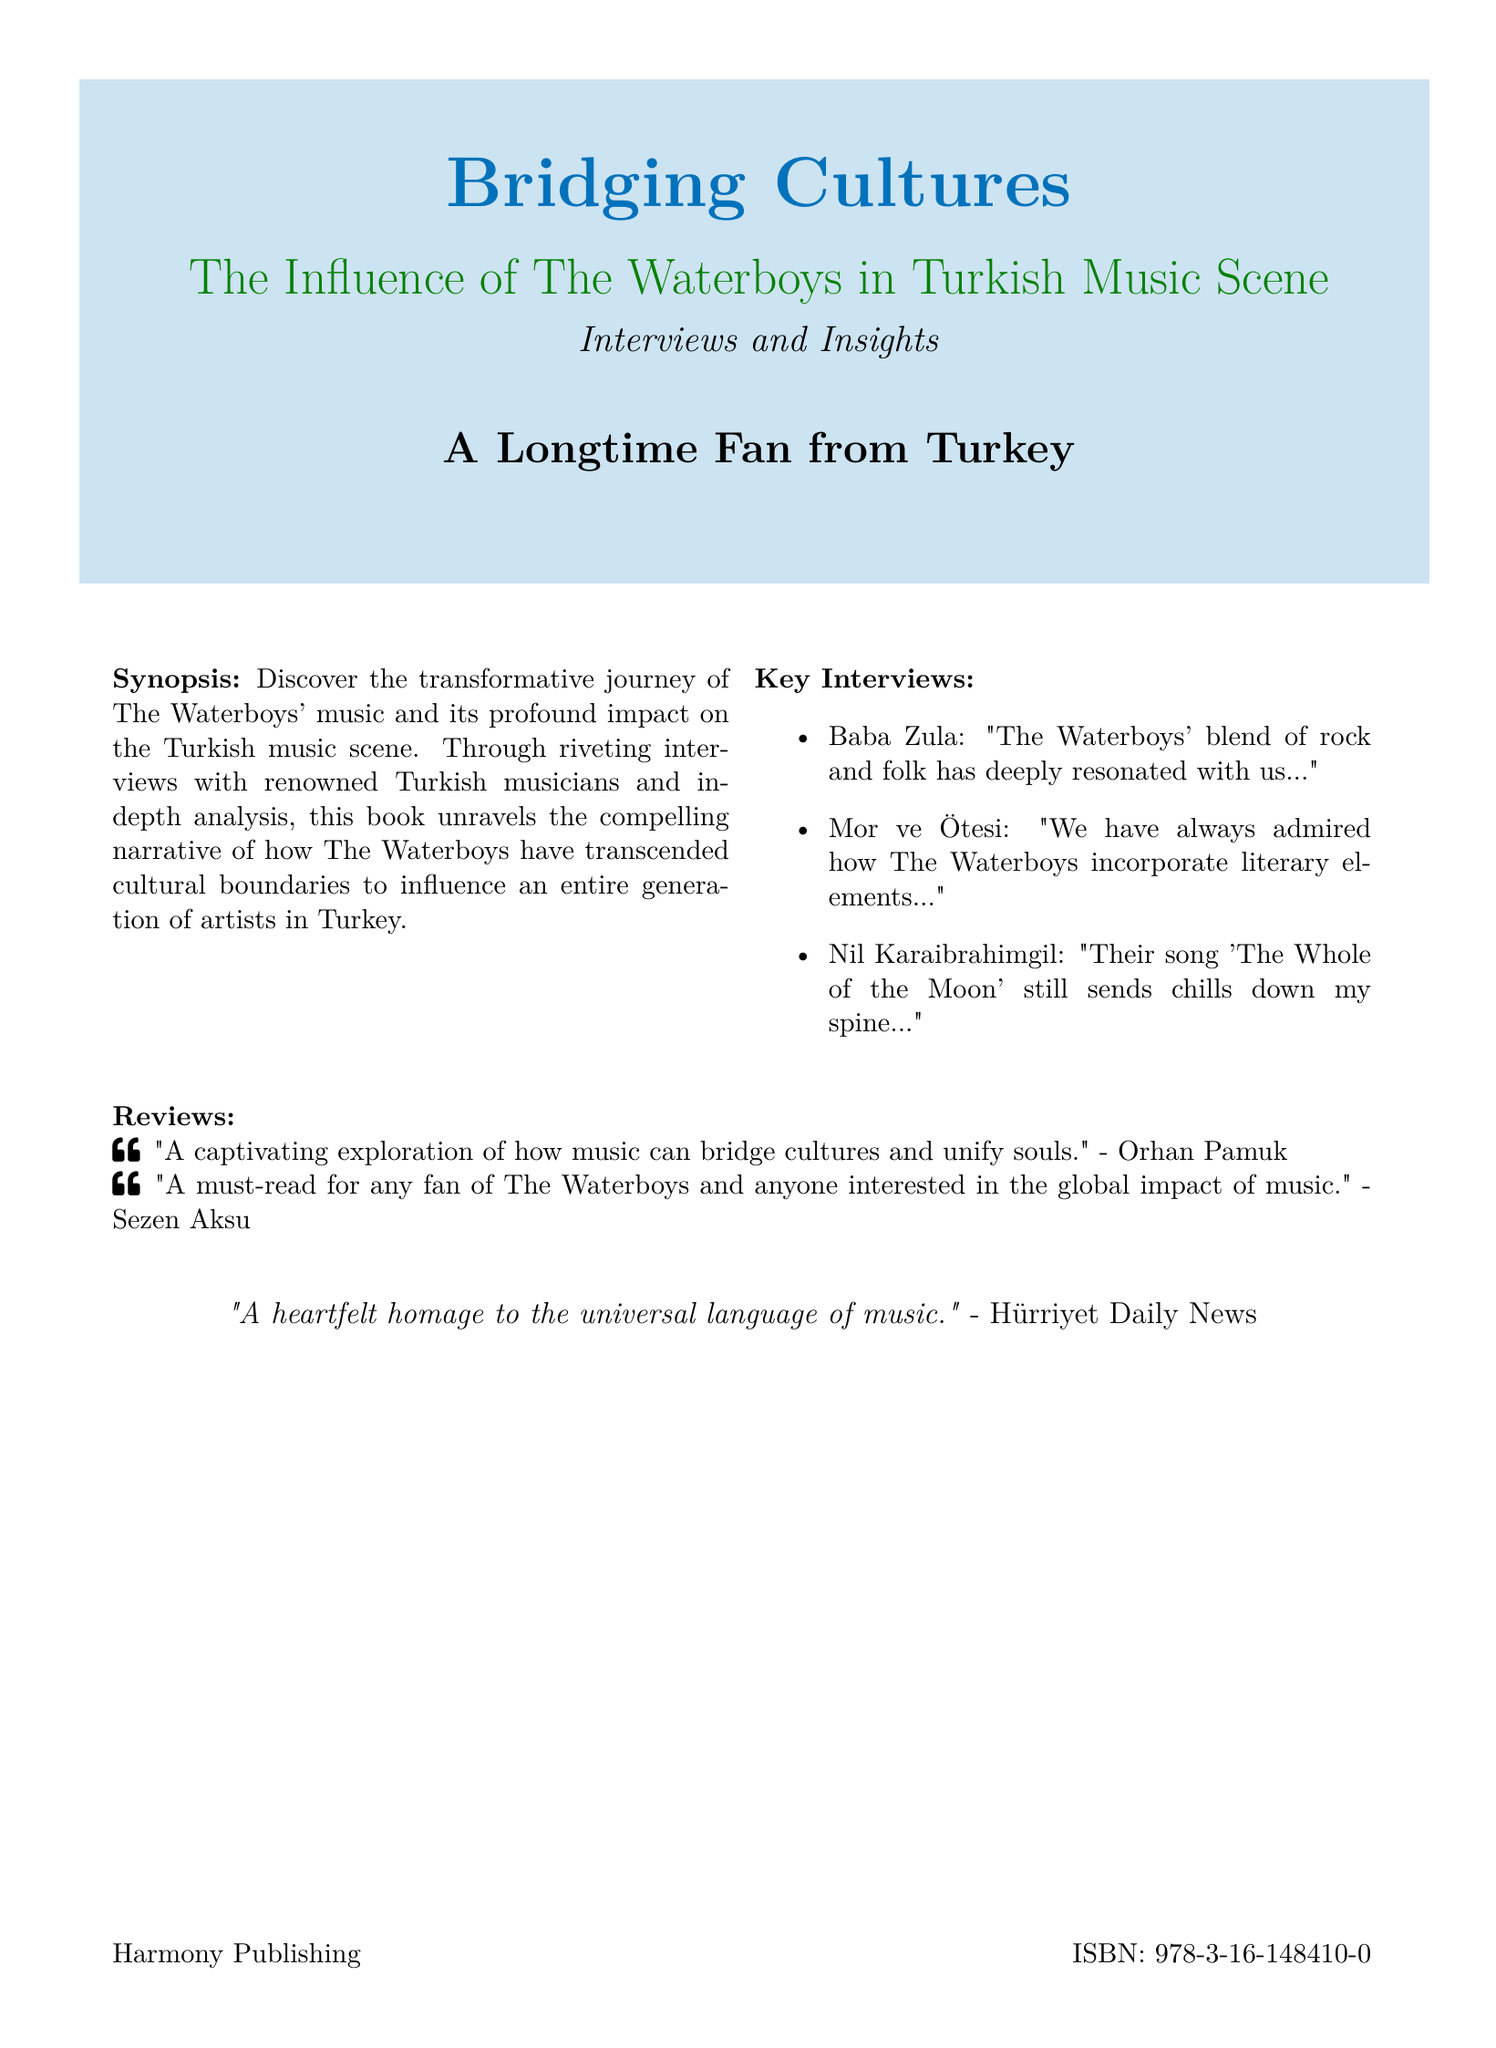What is the title of the book? The title of the book is prominently displayed in large font on the cover.
Answer: Bridging Cultures What is the main theme of the book? The theme is highlighted in the subtitle, which describes the book's focus on cultural influence.
Answer: The Influence of The Waterboys in Turkish Music Scene Who is the author of the book? The author's identity is noted at the bottom of the cover, indicating their connection to the subject.
Answer: A Longtime Fan from Turkey What is the ISBN of the book? The ISBN is provided in a small font at the bottom of the cover for identification.
Answer: 978-3-16-148410-0 Which musician said, "Their song 'The Whole of the Moon' still sends chills down my spine..."? The quote is attributed to a specific Turkish musician mentioned in the key interviews section.
Answer: Nil Karaibrahimgil Who praised the book as "A must-read for any fan of The Waterboys"? The author of the review is listed alongside the quote in the reviews section.
Answer: Sezen Aksu What color is used for the book's title? The title is displayed in a distinct color that contrasts with the background, making it stand out.
Answer: Turkish blue Which publication featured the quote about music as a universal language? The source of the quote is specified at the bottom of the reviews section.
Answer: Hürriyet Daily News What type of publication is this document? The structure and content indicate its categorization as a specific type of printed material.
Answer: Book cover 